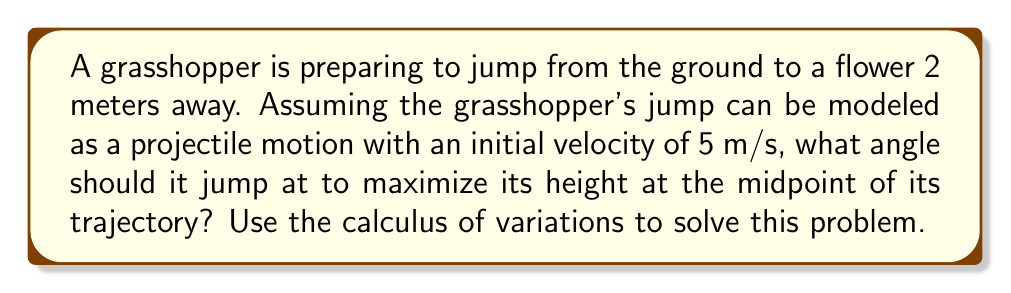Give your solution to this math problem. To solve this problem, we'll use the calculus of variations and follow these steps:

1) First, let's recall the equations of projectile motion:
   $$x(t) = v_0 \cos(\theta) t$$
   $$y(t) = v_0 \sin(\theta) t - \frac{1}{2}gt^2$$

   where $v_0$ is the initial velocity, $\theta$ is the angle of launch, and $g$ is the acceleration due to gravity (9.8 m/s²).

2) We want to maximize the height at the midpoint of the trajectory. The midpoint occurs when $x = 1$ m (half of the total distance).

3) We can find the time to reach the midpoint:
   $$1 = v_0 \cos(\theta) t$$
   $$t = \frac{1}{v_0 \cos(\theta)}$$

4) Now, we substitute this time into the equation for y:
   $$y = v_0 \sin(\theta) \cdot \frac{1}{v_0 \cos(\theta)} - \frac{1}{2}g \cdot (\frac{1}{v_0 \cos(\theta)})^2$$

5) Simplify:
   $$y = \tan(\theta) - \frac{g}{2v_0^2 \cos^2(\theta)}$$

6) To find the maximum, we differentiate with respect to $\theta$ and set it to zero:
   $$\frac{dy}{d\theta} = \sec^2(\theta) + \frac{g}{v_0^2} \cdot \frac{\sin(\theta)}{\cos^3(\theta)} = 0$$

7) This equation simplifies to:
   $$\cos^3(\theta) = \frac{g}{v_0^2} \sin(\theta)$$

8) Given $v_0 = 5$ m/s and $g = 9.8$ m/s², we can solve this numerically to find:
   $$\theta \approx 0.9553 \text{ radians} \approx 54.74°$$

This angle maximizes the height at the midpoint of the trajectory.
Answer: $54.74°$ 